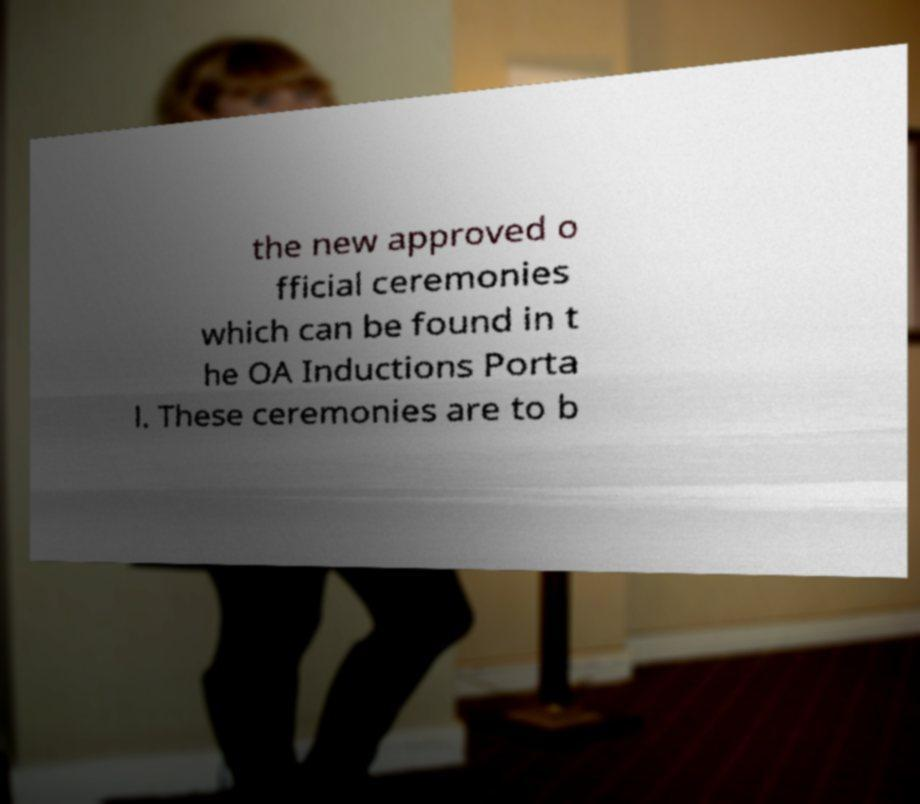For documentation purposes, I need the text within this image transcribed. Could you provide that? the new approved o fficial ceremonies which can be found in t he OA Inductions Porta l. These ceremonies are to b 